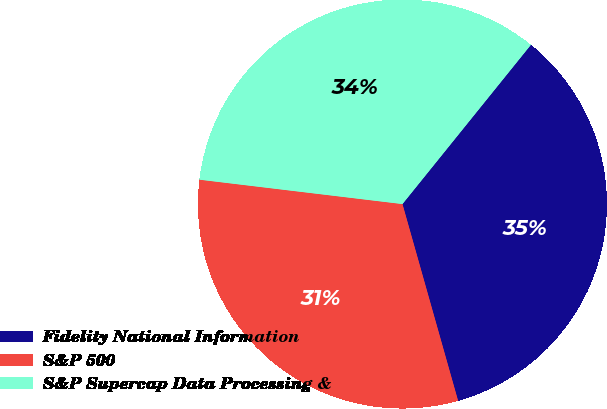Convert chart. <chart><loc_0><loc_0><loc_500><loc_500><pie_chart><fcel>Fidelity National Information<fcel>S&P 500<fcel>S&P Supercap Data Processing &<nl><fcel>34.81%<fcel>31.29%<fcel>33.9%<nl></chart> 